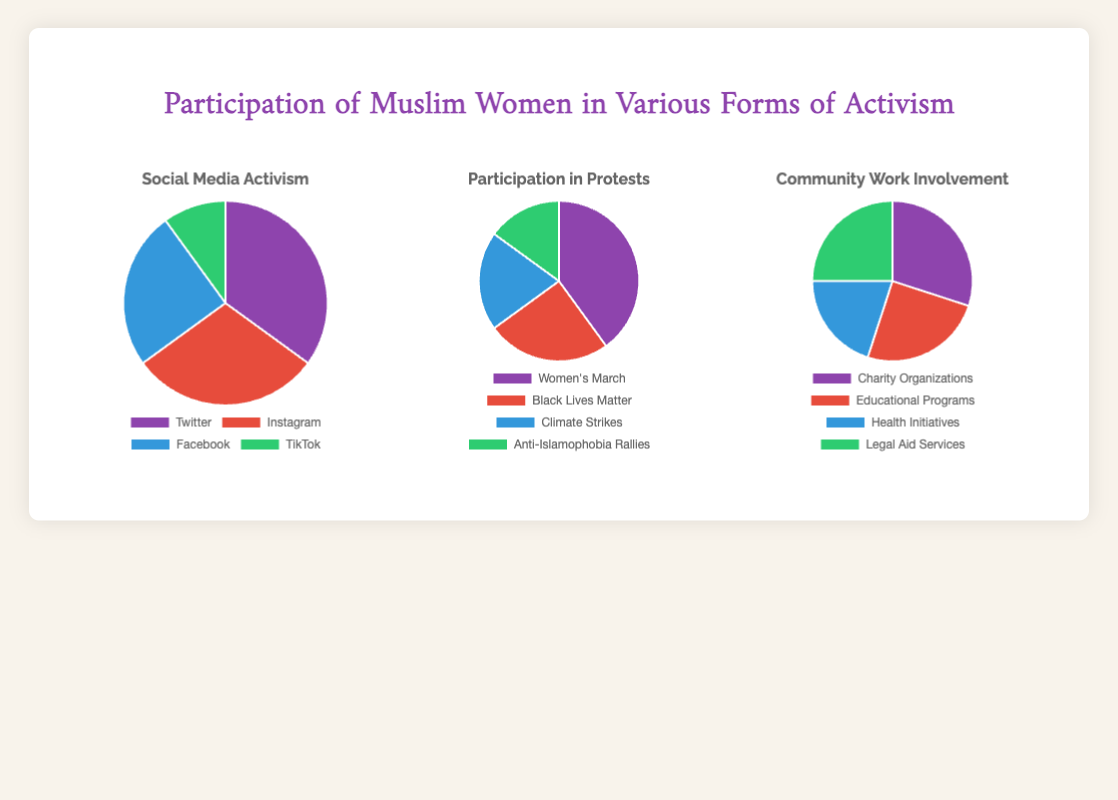What percentage of social media activism participation is through Instagram? First, observe the "Social Media Activism" pie chart. Instagram has 30%. Determine the total percentage by summing percentages of Twitter (35%), Instagram (30%), Facebook (25%), and TikTok (10%), which equals 100%. Therefore, Instagram's share is 30/100*100% = 30%.
Answer: 30% Which protest had the highest participation by Muslim women? Look at the "Participation in Protests" pie chart. Women's March is displayed as the largest portion at 40%.
Answer: Women's March What is the combined percentage of participation in Facebook and TikTok for social media activism? In the "Social Media Activism" pie chart, Facebook has 25% and TikTok has 10%. Add these percentages together: 25% + 10% = 35%.
Answer: 35% How does the participation in Anti-Islamophobia Rallies compare to Climate Strikes? In the "Participation in Protests" pie chart, Anti-Islamophobia Rallies have 15% and Climate Strikes have 20%. Climate Strikes have a higher participation rate (20%) compared to Anti-Islamophobia Rallies (15%).
Answer: Climate Strikes have higher participation Which form of community work has equal participation of 25%? Observing the "Community Work Involvement" pie chart, Educational Programs and Legal Aid Services both show equal participation of 25%.
Answer: Educational Programs and Legal Aid Services What is the total percentage of participation in Women's March and Black Lives Matter protests combined? From the "Participation in Protests" pie chart, Women's March has 40% and Black Lives Matter has 25%. Adding them: 40% + 25% = 65%.
Answer: 65% In community work, which has greater participation: Health Initiatives or Charity Organizations? In the "Community Work Involvement" pie chart, Health Initiatives have 20% and Charity Organizations have 30%. Charity Organizations have higher participation.
Answer: Charity Organizations What percentage of Social Media activism is done through Twitter? The "Social Media Activism" pie chart shows Twitter with 35%.
Answer: 35% If TikTok's participation percentage doubled, what would be the new percentage? The current participation for TikTok in the "Social Media Activism" pie chart is 10%. Doubling this: 10% * 2 = 20%.
Answer: 20% Is participation in the Women's March greater than in all social media platforms combined? First, sum social media platforms participation: Twitter (35%) + Instagram (30%) + Facebook (25%) + TikTok (10%) = 100%. The Women's March alone is 40%, thus, Women's March participation is not greater than all social media platforms combined.
Answer: No 